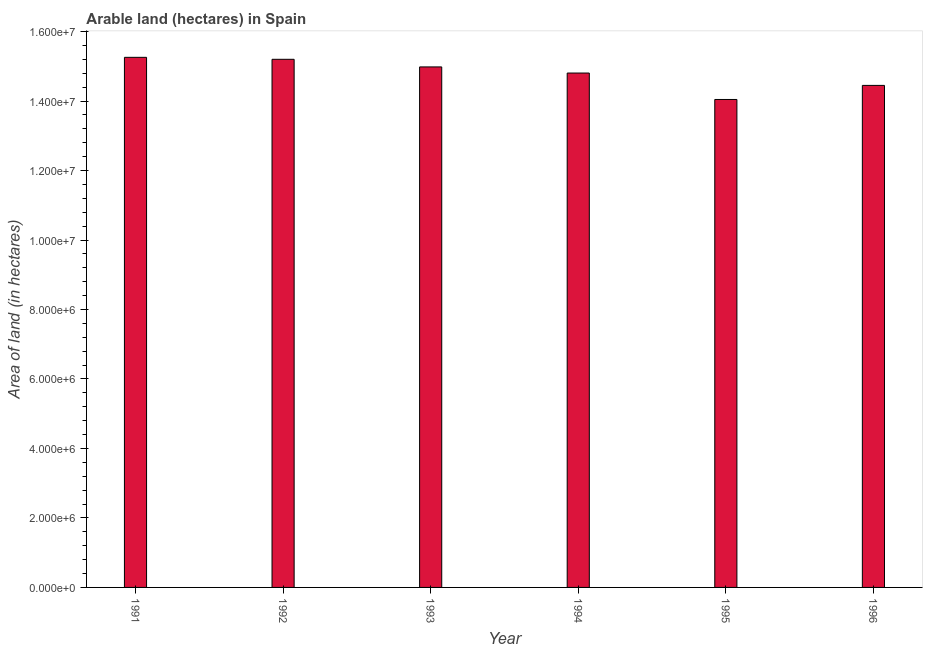Does the graph contain any zero values?
Make the answer very short. No. What is the title of the graph?
Give a very brief answer. Arable land (hectares) in Spain. What is the label or title of the X-axis?
Make the answer very short. Year. What is the label or title of the Y-axis?
Keep it short and to the point. Area of land (in hectares). What is the area of land in 1992?
Your answer should be compact. 1.52e+07. Across all years, what is the maximum area of land?
Make the answer very short. 1.53e+07. Across all years, what is the minimum area of land?
Your answer should be very brief. 1.40e+07. In which year was the area of land maximum?
Offer a very short reply. 1991. In which year was the area of land minimum?
Make the answer very short. 1995. What is the sum of the area of land?
Your response must be concise. 8.87e+07. What is the difference between the area of land in 1994 and 1996?
Give a very brief answer. 3.56e+05. What is the average area of land per year?
Provide a short and direct response. 1.48e+07. What is the median area of land?
Provide a short and direct response. 1.49e+07. In how many years, is the area of land greater than 14400000 hectares?
Ensure brevity in your answer.  5. Do a majority of the years between 1992 and 1994 (inclusive) have area of land greater than 5600000 hectares?
Offer a very short reply. Yes. What is the ratio of the area of land in 1991 to that in 1995?
Your answer should be very brief. 1.09. Is the area of land in 1992 less than that in 1994?
Your response must be concise. No. Is the difference between the area of land in 1992 and 1995 greater than the difference between any two years?
Give a very brief answer. No. What is the difference between the highest and the second highest area of land?
Make the answer very short. 5.70e+04. Is the sum of the area of land in 1991 and 1992 greater than the maximum area of land across all years?
Make the answer very short. Yes. What is the difference between the highest and the lowest area of land?
Ensure brevity in your answer.  1.21e+06. How many bars are there?
Give a very brief answer. 6. How many years are there in the graph?
Offer a very short reply. 6. What is the difference between two consecutive major ticks on the Y-axis?
Give a very brief answer. 2.00e+06. Are the values on the major ticks of Y-axis written in scientific E-notation?
Make the answer very short. Yes. What is the Area of land (in hectares) of 1991?
Give a very brief answer. 1.53e+07. What is the Area of land (in hectares) in 1992?
Your answer should be very brief. 1.52e+07. What is the Area of land (in hectares) of 1993?
Give a very brief answer. 1.50e+07. What is the Area of land (in hectares) in 1994?
Ensure brevity in your answer.  1.48e+07. What is the Area of land (in hectares) of 1995?
Your response must be concise. 1.40e+07. What is the Area of land (in hectares) of 1996?
Your answer should be very brief. 1.44e+07. What is the difference between the Area of land (in hectares) in 1991 and 1992?
Your response must be concise. 5.70e+04. What is the difference between the Area of land (in hectares) in 1991 and 1993?
Keep it short and to the point. 2.76e+05. What is the difference between the Area of land (in hectares) in 1991 and 1994?
Your answer should be very brief. 4.52e+05. What is the difference between the Area of land (in hectares) in 1991 and 1995?
Give a very brief answer. 1.21e+06. What is the difference between the Area of land (in hectares) in 1991 and 1996?
Provide a succinct answer. 8.08e+05. What is the difference between the Area of land (in hectares) in 1992 and 1993?
Ensure brevity in your answer.  2.19e+05. What is the difference between the Area of land (in hectares) in 1992 and 1994?
Offer a terse response. 3.95e+05. What is the difference between the Area of land (in hectares) in 1992 and 1995?
Ensure brevity in your answer.  1.16e+06. What is the difference between the Area of land (in hectares) in 1992 and 1996?
Offer a terse response. 7.51e+05. What is the difference between the Area of land (in hectares) in 1993 and 1994?
Your answer should be compact. 1.76e+05. What is the difference between the Area of land (in hectares) in 1993 and 1995?
Your answer should be very brief. 9.37e+05. What is the difference between the Area of land (in hectares) in 1993 and 1996?
Offer a very short reply. 5.32e+05. What is the difference between the Area of land (in hectares) in 1994 and 1995?
Give a very brief answer. 7.61e+05. What is the difference between the Area of land (in hectares) in 1994 and 1996?
Give a very brief answer. 3.56e+05. What is the difference between the Area of land (in hectares) in 1995 and 1996?
Your response must be concise. -4.05e+05. What is the ratio of the Area of land (in hectares) in 1991 to that in 1993?
Provide a succinct answer. 1.02. What is the ratio of the Area of land (in hectares) in 1991 to that in 1994?
Your answer should be very brief. 1.03. What is the ratio of the Area of land (in hectares) in 1991 to that in 1995?
Make the answer very short. 1.09. What is the ratio of the Area of land (in hectares) in 1991 to that in 1996?
Your response must be concise. 1.06. What is the ratio of the Area of land (in hectares) in 1992 to that in 1995?
Your answer should be very brief. 1.08. What is the ratio of the Area of land (in hectares) in 1992 to that in 1996?
Keep it short and to the point. 1.05. What is the ratio of the Area of land (in hectares) in 1993 to that in 1994?
Provide a short and direct response. 1.01. What is the ratio of the Area of land (in hectares) in 1993 to that in 1995?
Keep it short and to the point. 1.07. What is the ratio of the Area of land (in hectares) in 1993 to that in 1996?
Make the answer very short. 1.04. What is the ratio of the Area of land (in hectares) in 1994 to that in 1995?
Make the answer very short. 1.05. 